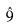Convert formula to latex. <formula><loc_0><loc_0><loc_500><loc_500>\hat { 9 }</formula> 